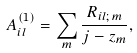<formula> <loc_0><loc_0><loc_500><loc_500>A ^ { ( 1 ) } _ { i l } = \sum _ { m } \frac { R _ { i l ; \, m } } { j - z _ { m } } ,</formula> 